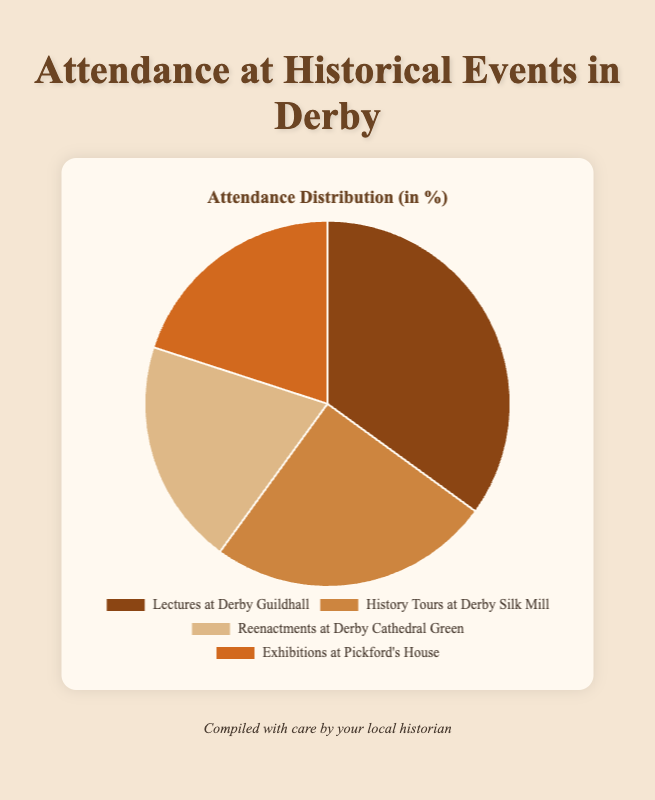Which event has the highest attendance? Examining the pie chart, the largest segment represents "Lectures at Derby Guildhall" with 35%.
Answer: Lectures at Derby Guildhall Which two events have the same attendance? The segments for "Reenactments at Derby Cathedral Green" and "Exhibitions at Pickford’s House" both show 20%.
Answer: Reenactments at Derby Cathedral Green and Exhibitions at Pickford’s House How much higher is the attendance for "Lectures at Derby Guildhall" compared to "History Tours at Derby Silk Mill"? The attendance for "Lectures at Derby Guildhall" is 35% and for "History Tours at Derby Silk Mill" is 25%. The difference is 35% - 25%.
Answer: 10% What is the total attendance percentage for the least attended events combined? The least attended events are "Reenactments at Derby Cathedral Green" and "Exhibitions at Pickford’s House," each with 20%. Their combined attendance is 20% + 20%.
Answer: 40% What color represents "History Tours at Derby Silk Mill"? Observing the pie chart, the segment for "History Tours at Derby Silk Mill" is brown.
Answer: brown Which event has the smallest segment in the chart? The smallest segments in the pie chart represent both "Reenactments at Derby Cathedral Green" and "Exhibitions at Pickford’s House," each with 20%.
Answer: Reenactments at Derby Cathedral Green and Exhibitions at Pickford’s House Which events have an equal share of attendance in the pie chart? The equal shares in the pie chart are represented by "Reenactments at Derby Cathedral Green" and "Exhibitions at Pickford’s House" with 20% each.
Answer: Reenactments at Derby Cathedral Green and Exhibitions at Pickford’s House By how much does "Lectures at Derby Guildhall" exceed the combined percentage of "Reenactments at Derby Cathedral Green" and "Exhibitions at Pickford's House"? "Lectures at Derby Guildhall" is 35%. The combined percentage for "Reenactments at Derby Cathedral Green" and "Exhibitions at Pickford’s House" is 20% + 20% = 40%. The difference is 40% - 35%.
Answer: -5% What percentage of the total attendance does "History Tours at Derby Silk Mill" represent compared to "Lectures at Derby Guildhall"? "History Tours at Derby Silk Mill" represent 25% and "Lectures at Derby Guildhall" represent 35%. The comparison is 25% / 35% * 100%.
Answer: 71.4% What is the combined percentage of attendance for the two most attended events? The most attended events are "Lectures at Derby Guildhall" (35%) and "History Tours at Derby Silk Mill" (25%). Their combined attendance is 35% + 25%.
Answer: 60% 